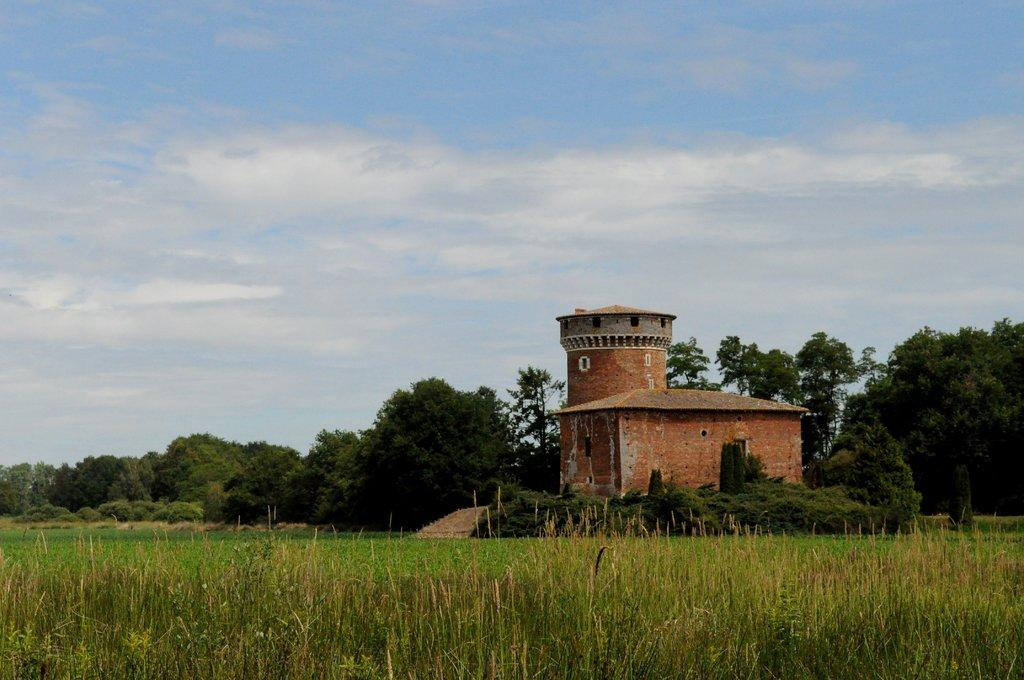What type of structure is visible in the image? There is a building in the image. What type of vegetation is present in the image? There is grass in the image. Are there any plants visible in the image? Yes, there is a plant in the image. How would you describe the sky in the image? The sky is cloudy in the image. What hobbies can be seen being practiced in the image? There is no indication of any hobbies being practiced in the image. What is the limit of the plant's growth in the image? The image does not provide information about the plant's growth or any limits to it. 